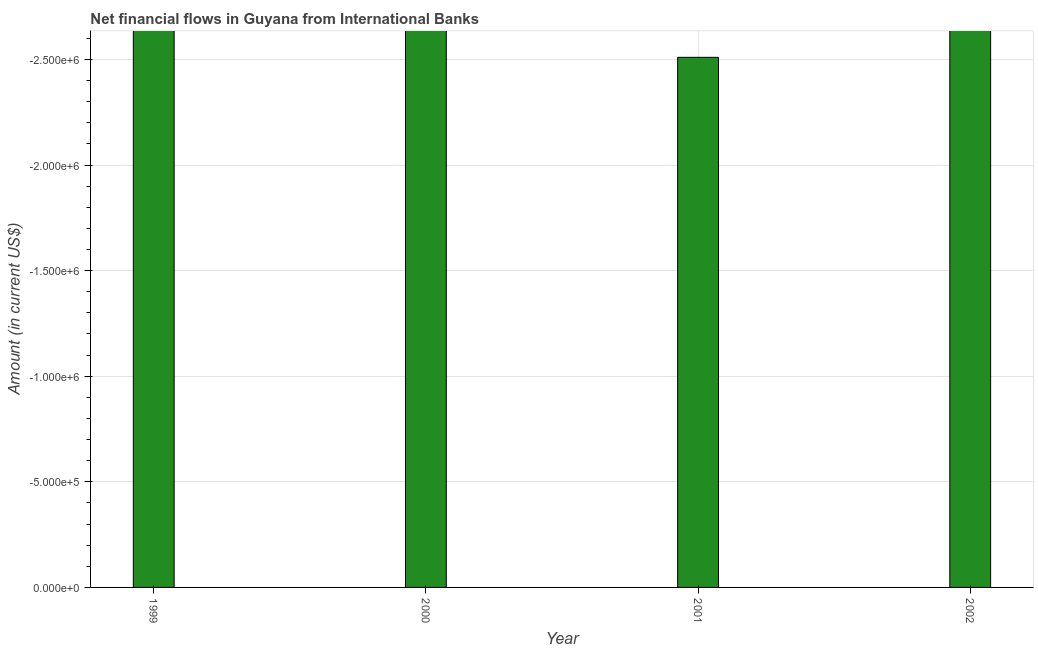Does the graph contain any zero values?
Keep it short and to the point. Yes. Does the graph contain grids?
Keep it short and to the point. Yes. What is the title of the graph?
Make the answer very short. Net financial flows in Guyana from International Banks. What is the label or title of the X-axis?
Offer a terse response. Year. What is the average net financial flows from ibrd per year?
Ensure brevity in your answer.  0. In how many years, is the net financial flows from ibrd greater than -2500000 US$?
Your response must be concise. 0. In how many years, is the net financial flows from ibrd greater than the average net financial flows from ibrd taken over all years?
Provide a short and direct response. 0. Are all the bars in the graph horizontal?
Ensure brevity in your answer.  No. What is the difference between two consecutive major ticks on the Y-axis?
Your response must be concise. 5.00e+05. Are the values on the major ticks of Y-axis written in scientific E-notation?
Keep it short and to the point. Yes. What is the Amount (in current US$) in 2001?
Ensure brevity in your answer.  0. 